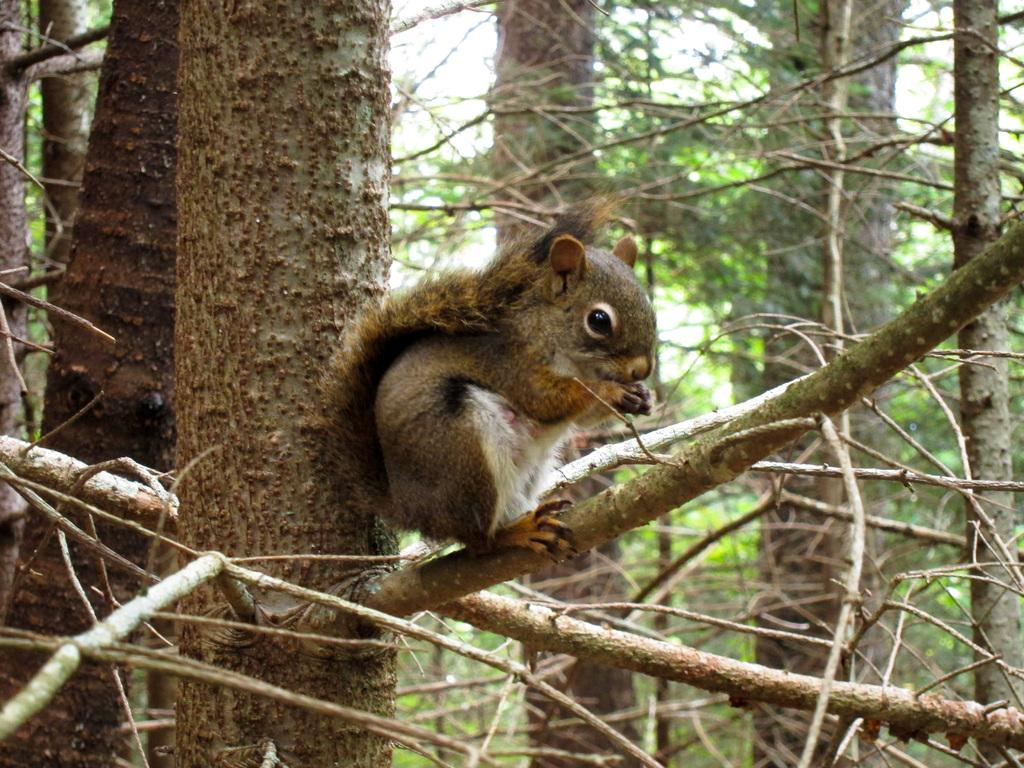What type of plant can be seen in the image? There is a tree in the image. What animal is present in the image? There is a squirrel in the middle of the image. What is the fifth route taken by the squirrel in the image? There is no indication of multiple routes or a specific number of routes taken by the squirrel in the image. --- Facts: 1. There is a car in the image. 2. The car is parked on the street. 3. There are buildings in the background. 4. The sky is visible in the image. Absurd Topics: dance, ocean, guitar Conversation: What type of vehicle is in the image? There is a car in the image. Where is the car located? The car is parked on the street. What can be seen in the background of the image? There are buildings in the background. What is visible at the top of the image? The sky is visible in the image. Reasoning: Let's think step by step in order to produce the conversation. We start by identifying the main subject in the image, which is the car. Then, we expand the conversation to include the location of the car, the background, and the sky. Each question is designed to elicit a specific detail about the image that is known from the provided facts. Absurd Question/Answer: Can you see the guitar being played by the ocean in the image? A: There is no guitar or ocean present in the image; it features a car parked on the street with buildings and the sky visible in the background. 